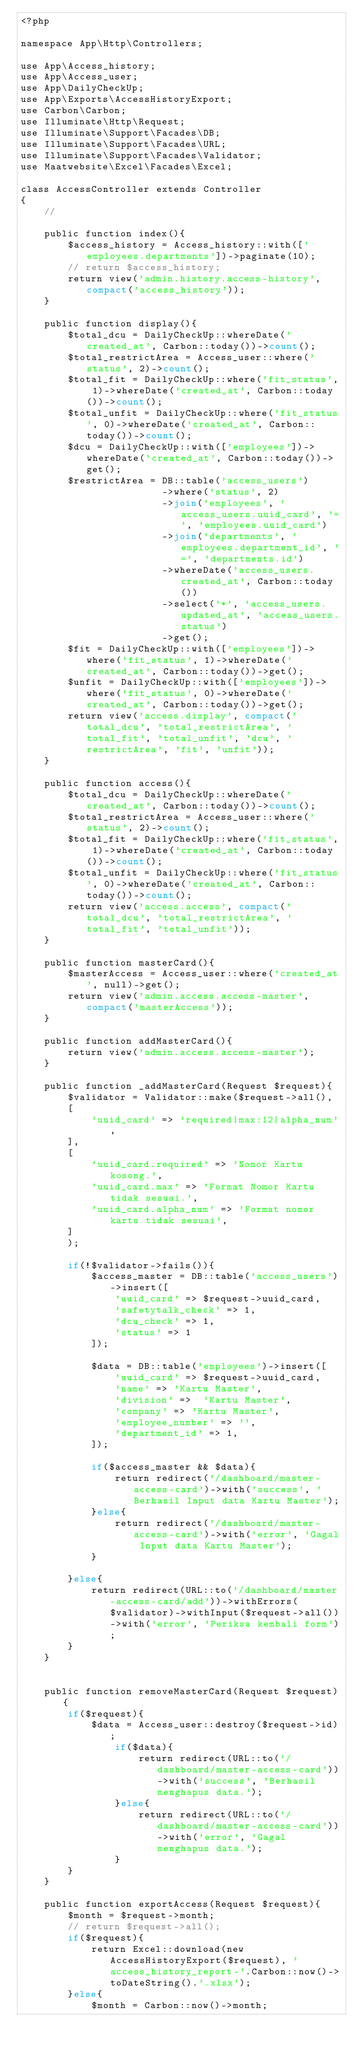Convert code to text. <code><loc_0><loc_0><loc_500><loc_500><_PHP_><?php

namespace App\Http\Controllers;

use App\Access_history;
use App\Access_user;
use App\DailyCheckUp;
use App\Exports\AccessHistoryExport;
use Carbon\Carbon;
use Illuminate\Http\Request;
use Illuminate\Support\Facades\DB;
use Illuminate\Support\Facades\URL;
use Illuminate\Support\Facades\Validator;
use Maatwebsite\Excel\Facades\Excel;

class AccessController extends Controller
{
    //

    public function index(){
        $access_history = Access_history::with(['employees.departments'])->paginate(10);
        // return $access_history;
        return view('admin.history.access-history', compact('access_history'));
    }

    public function display(){
        $total_dcu = DailyCheckUp::whereDate('created_at', Carbon::today())->count();
        $total_restrictArea = Access_user::where('status', 2)->count();
        $total_fit = DailyCheckUp::where('fit_status', 1)->whereDate('created_at', Carbon::today())->count();
        $total_unfit = DailyCheckUp::where('fit_status', 0)->whereDate('created_at', Carbon::today())->count();
        $dcu = DailyCheckUp::with(['employees'])->whereDate('created_at', Carbon::today())->get();
        $restrictArea = DB::table('access_users')
                        ->where('status', 2)
                        ->join('employees', 'access_users.uuid_card', '=', 'employees.uuid_card')
                        ->join('departments', 'employees.department_id', '=', 'departments.id')
                        ->whereDate('access_users.created_at', Carbon::today())
                        ->select('*', 'access_users.updated_at', 'access_users.status')
                        ->get();
        $fit = DailyCheckUp::with(['employees'])->where('fit_status', 1)->whereDate('created_at', Carbon::today())->get();
        $unfit = DailyCheckUp::with(['employees'])->where('fit_status', 0)->whereDate('created_at', Carbon::today())->get();
        return view('access.display', compact('total_dcu', 'total_restrictArea', 'total_fit', 'total_unfit', 'dcu', 'restrictArea', 'fit', 'unfit'));
    }

    public function access(){
        $total_dcu = DailyCheckUp::whereDate('created_at', Carbon::today())->count();
        $total_restrictArea = Access_user::where('status', 2)->count();
        $total_fit = DailyCheckUp::where('fit_status', 1)->whereDate('created_at', Carbon::today())->count();
        $total_unfit = DailyCheckUp::where('fit_status', 0)->whereDate('created_at', Carbon::today())->count();
        return view('access.access', compact('total_dcu', 'total_restrictArea', 'total_fit', 'total_unfit'));
    }

    public function masterCard(){
        $masterAccess = Access_user::where('created_at', null)->get();
        return view('admin.access.access-master', compact('masterAccess'));
    }

    public function addMasterCard(){
        return view('admin.access.access-master');
    }

    public function _addMasterCard(Request $request){
        $validator = Validator::make($request->all(),
        [
            'uuid_card' => 'required|max:12|alpha_num',
        ],
        [
            'uuid_card.required' => 'Nomor Kartu kosong.',
            'uuid_card.max' => 'Format Nomor Kartu tidak sesuai.',
            'uuid_card.alpha_num' => 'Format nomor kartu tidak sesuai',
        ]
        );

        if(!$validator->fails()){
            $access_master = DB::table('access_users')->insert([
                'uuid_card' => $request->uuid_card,
                'safetytalk_check' => 1,
                'dcu_check' => 1,
                'status' => 1
            ]);

            $data = DB::table('employees')->insert([
                'uuid_card' => $request->uuid_card,
                'name' => 'Kartu Master',
                'division' =>  'Kartu Master',
                'company' => 'Kartu Master',
                'employee_number' => '',
                'department_id' => 1,
            ]);

            if($access_master && $data){
                return redirect('/dashboard/master-access-card')->with('success', 'Berhasil Input data Kartu Master');
            }else{
                return redirect('/dashboard/master-access-card')->with('error', 'Gagal Input data Kartu Master');
            }

        }else{
            return redirect(URL::to('/dashboard/master-access-card/add'))->withErrors($validator)->withInput($request->all())->with('error', 'Periksa kembali form');
        }
    }


    public function removeMasterCard(Request $request){
        if($request){
            $data = Access_user::destroy($request->id);
                if($data){
                    return redirect(URL::to('/dashboard/master-access-card'))->with('success', 'Berhasil menghapus data.');
                }else{
                    return redirect(URL::to('/dashboard/master-access-card'))->with('error', 'Gagal menghapus data.');
                }
        }
    }

    public function exportAccess(Request $request){
        $month = $request->month;
        // return $request->all();
        if($request){
            return Excel::download(new AccessHistoryExport($request), 'access_history_report-'.Carbon::now()->toDateString().'.xlsx');
        }else{
            $month = Carbon::now()->month;</code> 